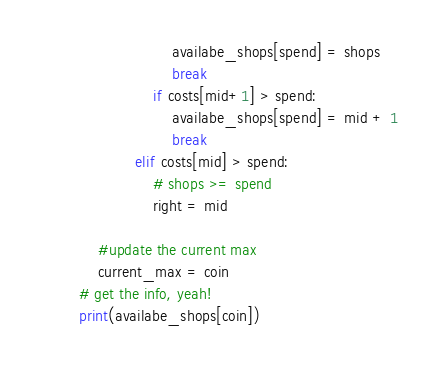Convert code to text. <code><loc_0><loc_0><loc_500><loc_500><_Python_>                            availabe_shops[spend] = shops
                            break
                        if costs[mid+1] > spend:
                            availabe_shops[spend] = mid + 1
                            break
                    elif costs[mid] > spend:
                        # shops >= spend
                        right = mid

            #update the current max
            current_max = coin
        # get the info, yeah!
        print(availabe_shops[coin])</code> 